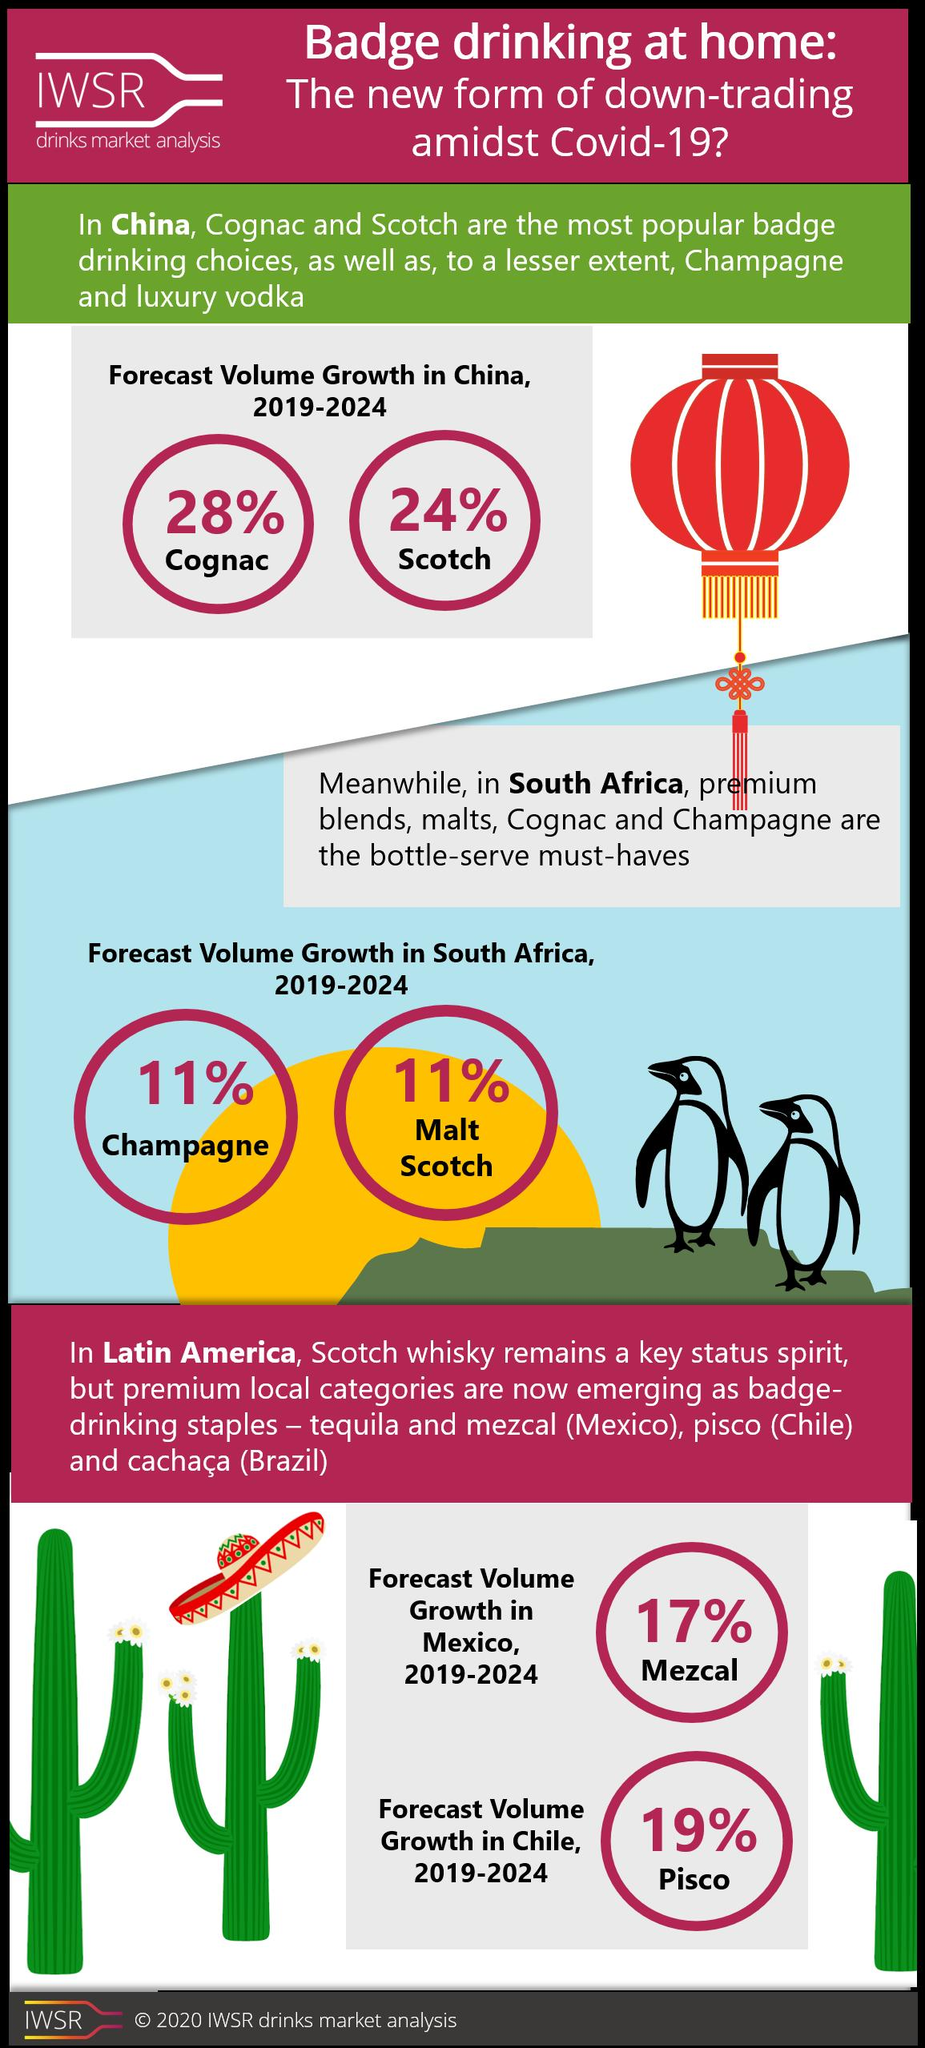Identify some key points in this picture. During 2019-2024, in Mexico, other than mezcal, tequila is the most popular drinking staple. The forecast volume growth of badge drinking of champagne in South Africa during 2019-2024 is expected to be 11%. During 2019-2024, the most popular drinking staple in Brazil is cachaça. The forecast for the growth of badge drinking of cognac in China during the period of 2019-2024 is expected to be 28%. The forecasted volume growth of badge drinking of Scotch in China from 2019 to 2024 is expected to be 24%. 